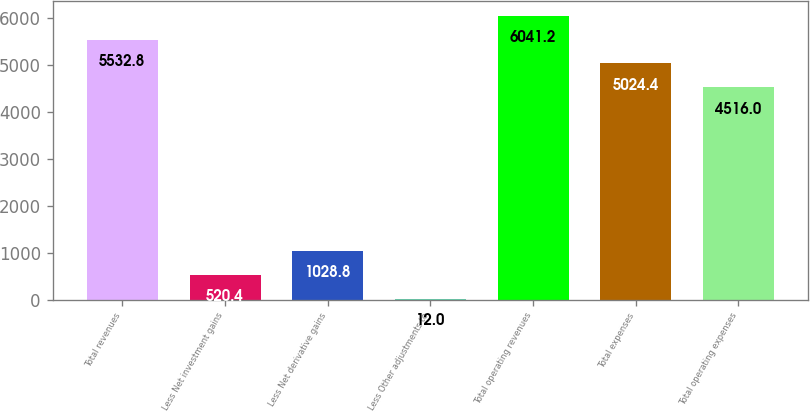Convert chart to OTSL. <chart><loc_0><loc_0><loc_500><loc_500><bar_chart><fcel>Total revenues<fcel>Less Net investment gains<fcel>Less Net derivative gains<fcel>Less Other adjustments to<fcel>Total operating revenues<fcel>Total expenses<fcel>Total operating expenses<nl><fcel>5532.8<fcel>520.4<fcel>1028.8<fcel>12<fcel>6041.2<fcel>5024.4<fcel>4516<nl></chart> 